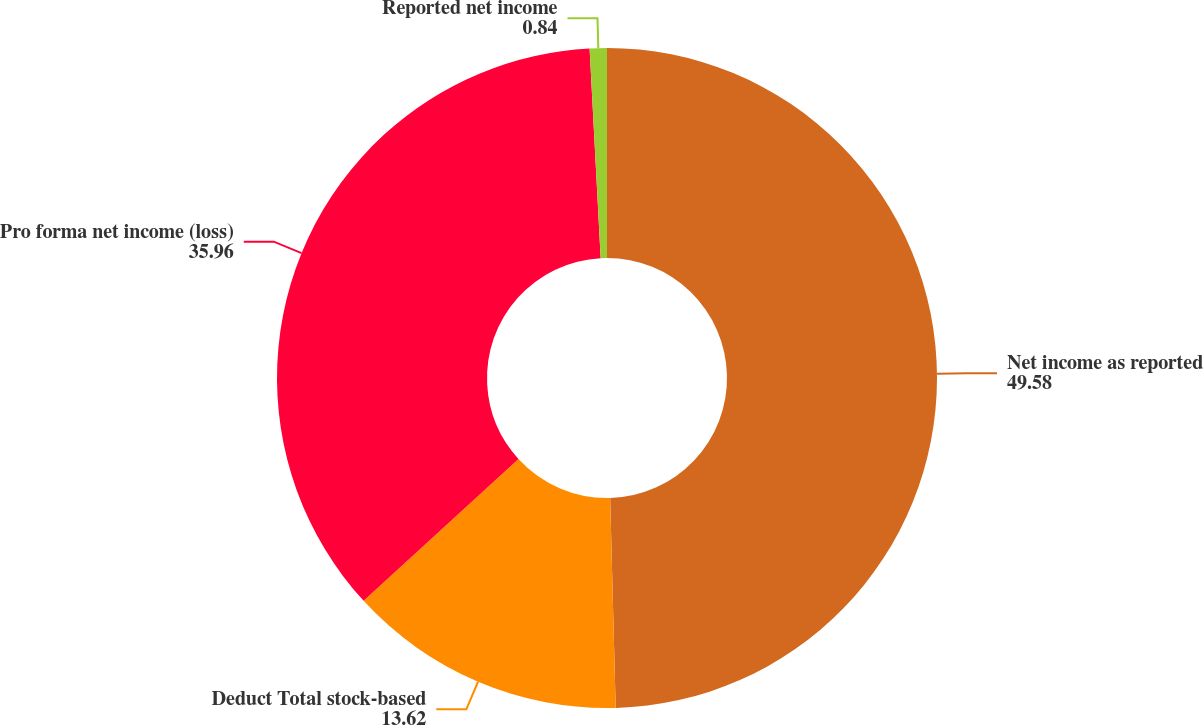<chart> <loc_0><loc_0><loc_500><loc_500><pie_chart><fcel>Net income as reported<fcel>Deduct Total stock-based<fcel>Pro forma net income (loss)<fcel>Reported net income<nl><fcel>49.58%<fcel>13.62%<fcel>35.96%<fcel>0.84%<nl></chart> 